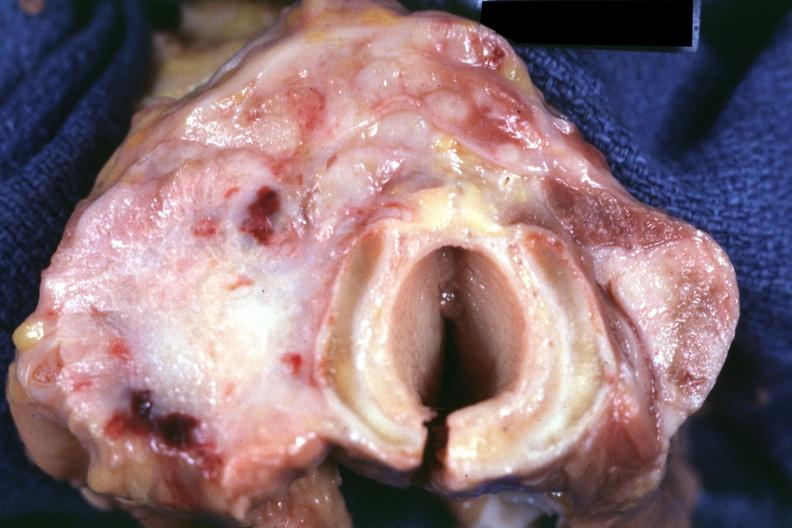what is section through thyroid and trachea had?
Answer the question using a single word or phrase. Colon carcinoma 